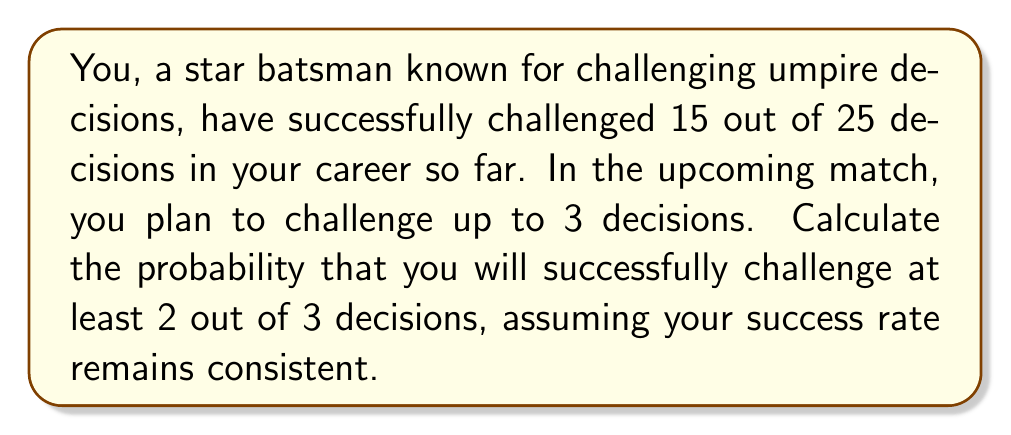What is the answer to this math problem? Let's approach this step-by-step:

1) First, we need to calculate your historical success rate:
   Success rate = $\frac{\text{Successful challenges}}{\text{Total challenges}} = \frac{15}{25} = 0.6$ or 60%

2) Now, we need to calculate the probability of at least 2 successes out of 3 challenges. This can happen in two ways:
   a) Exactly 2 successes out of 3
   b) All 3 successes

3) Let's use the binomial probability formula:
   $P(X = k) = \binom{n}{k} p^k (1-p)^{n-k}$
   Where:
   $n$ = number of trials (3 in this case)
   $k$ = number of successes
   $p$ = probability of success on each trial (0.6 in this case)

4) For exactly 2 successes:
   $P(X = 2) = \binom{3}{2} (0.6)^2 (0.4)^1$
   $= 3 \cdot 0.36 \cdot 0.4 = 0.432$

5) For 3 successes:
   $P(X = 3) = \binom{3}{3} (0.6)^3 (0.4)^0$
   $= 1 \cdot 0.216 \cdot 1 = 0.216$

6) The probability of at least 2 successes is the sum of these probabilities:
   $P(X \geq 2) = P(X = 2) + P(X = 3) = 0.432 + 0.216 = 0.648$
Answer: The probability of successfully challenging at least 2 out of 3 decisions is 0.648 or 64.8%. 